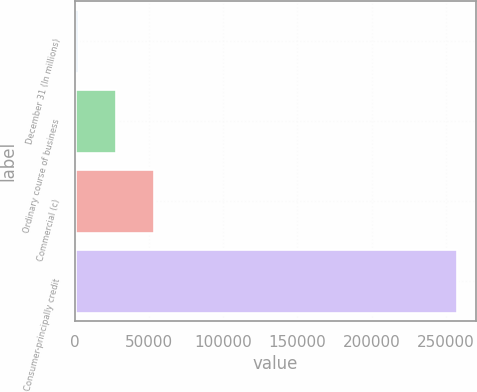Convert chart. <chart><loc_0><loc_0><loc_500><loc_500><bar_chart><fcel>December 31 (In millions)<fcel>Ordinary course of business<fcel>Commercial (c)<fcel>Consumer-principally credit<nl><fcel>2011<fcel>27574.5<fcel>53138<fcel>257646<nl></chart> 